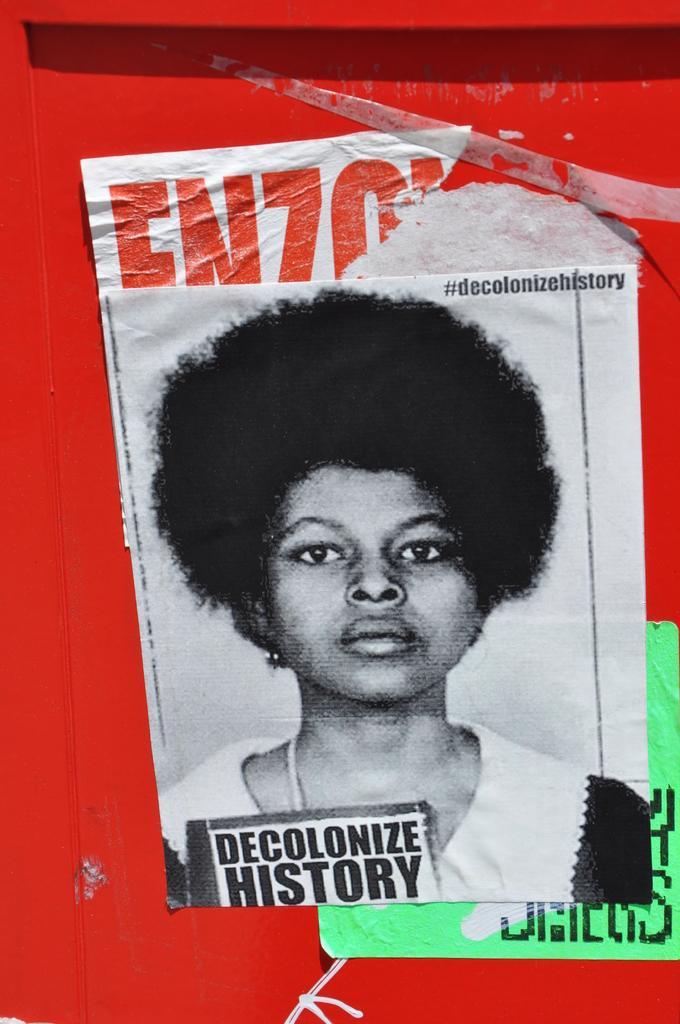Could you give a brief overview of what you see in this image? In this image there are poster with some text and image is attached to a structure which is in red color. 